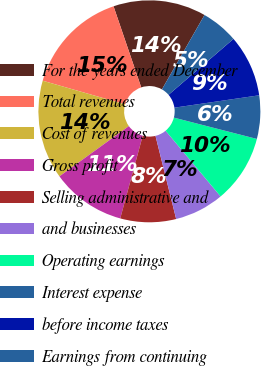Convert chart to OTSL. <chart><loc_0><loc_0><loc_500><loc_500><pie_chart><fcel>For the years ended December<fcel>Total revenues<fcel>Cost of revenues<fcel>Gross profit<fcel>Selling administrative and<fcel>and businesses<fcel>Operating earnings<fcel>Interest expense<fcel>before income taxes<fcel>Earnings from continuing<nl><fcel>13.51%<fcel>15.32%<fcel>14.41%<fcel>10.81%<fcel>8.11%<fcel>7.21%<fcel>9.91%<fcel>6.31%<fcel>9.01%<fcel>5.41%<nl></chart> 